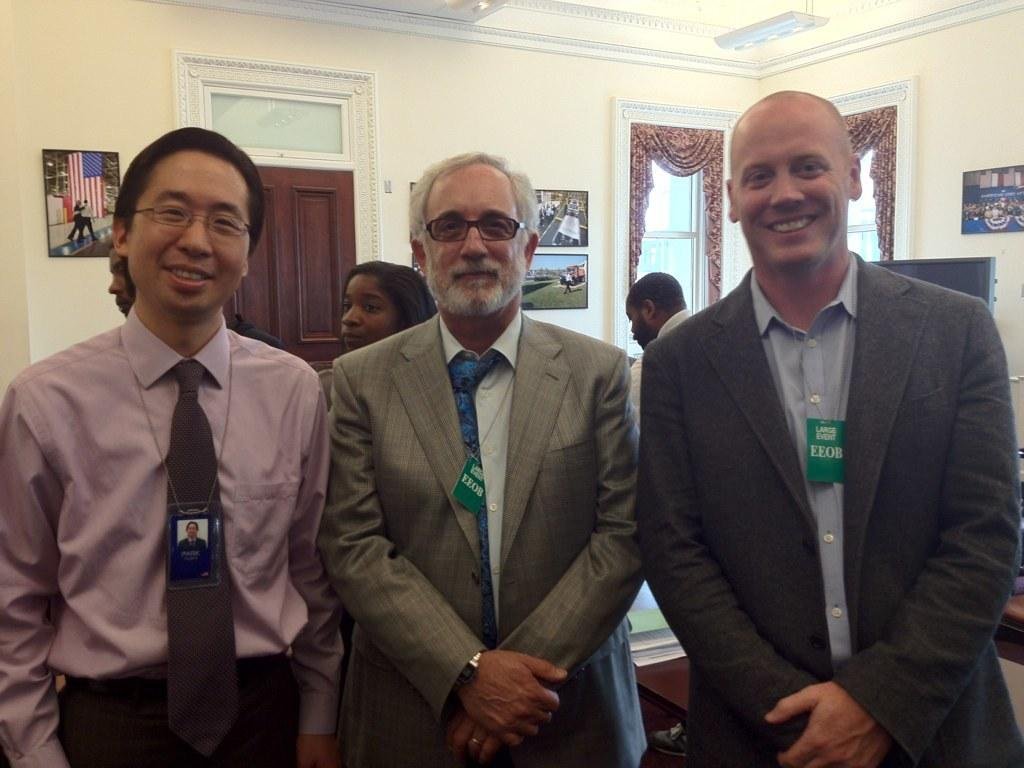How many people are present in the image? There are a few people in the image. What can be seen on the wall in the image? There is a wall with frames in the image. What architectural feature is present in the image? There is a door in the image. What is visible in the image that allows natural light to enter the room? There are windows in the image. What type of window treatment is present in the image? There are curtains associated with the windows. What part of the building is visible in the image? The roof is visible in the image. What color is the object mentioned in the image? There is a white-colored object in the image. How many plastic giants can be seen in the image? There are no plastic giants present in the image. What type of end is visible in the image? There is no end visible in the image; it is a room with a wall, frames, door, windows, curtains, roof, and white-colored object. 